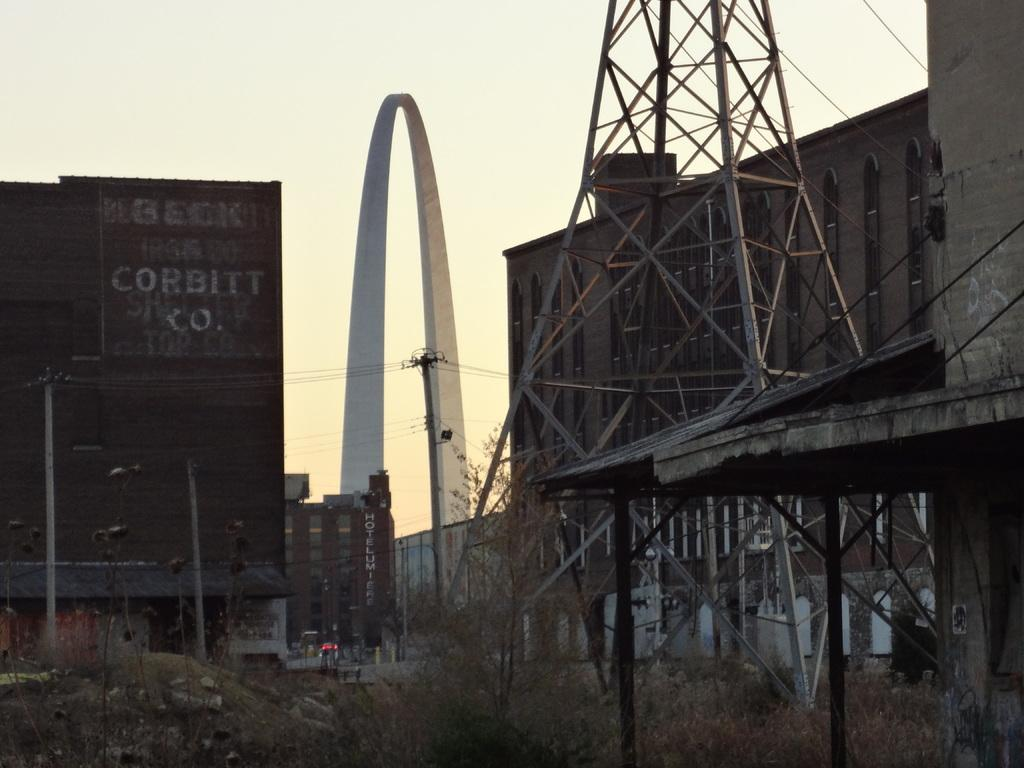What type of natural elements can be seen in the image? There are many trees in the image. What man-made structure is present in the image? There is a tower in the image. What can be seen in the background of the image? There are boards, poles, buildings, and the sky visible in the background of the image. What type of drum can be heard playing in the image? There is no drum present in the image, and therefore no sound can be heard. Can you describe the feather's effect on the image? There is no feather present in the image, so it cannot have any effect on the image. 